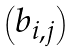Convert formula to latex. <formula><loc_0><loc_0><loc_500><loc_500>\begin{pmatrix} b _ { i , j } \end{pmatrix}</formula> 